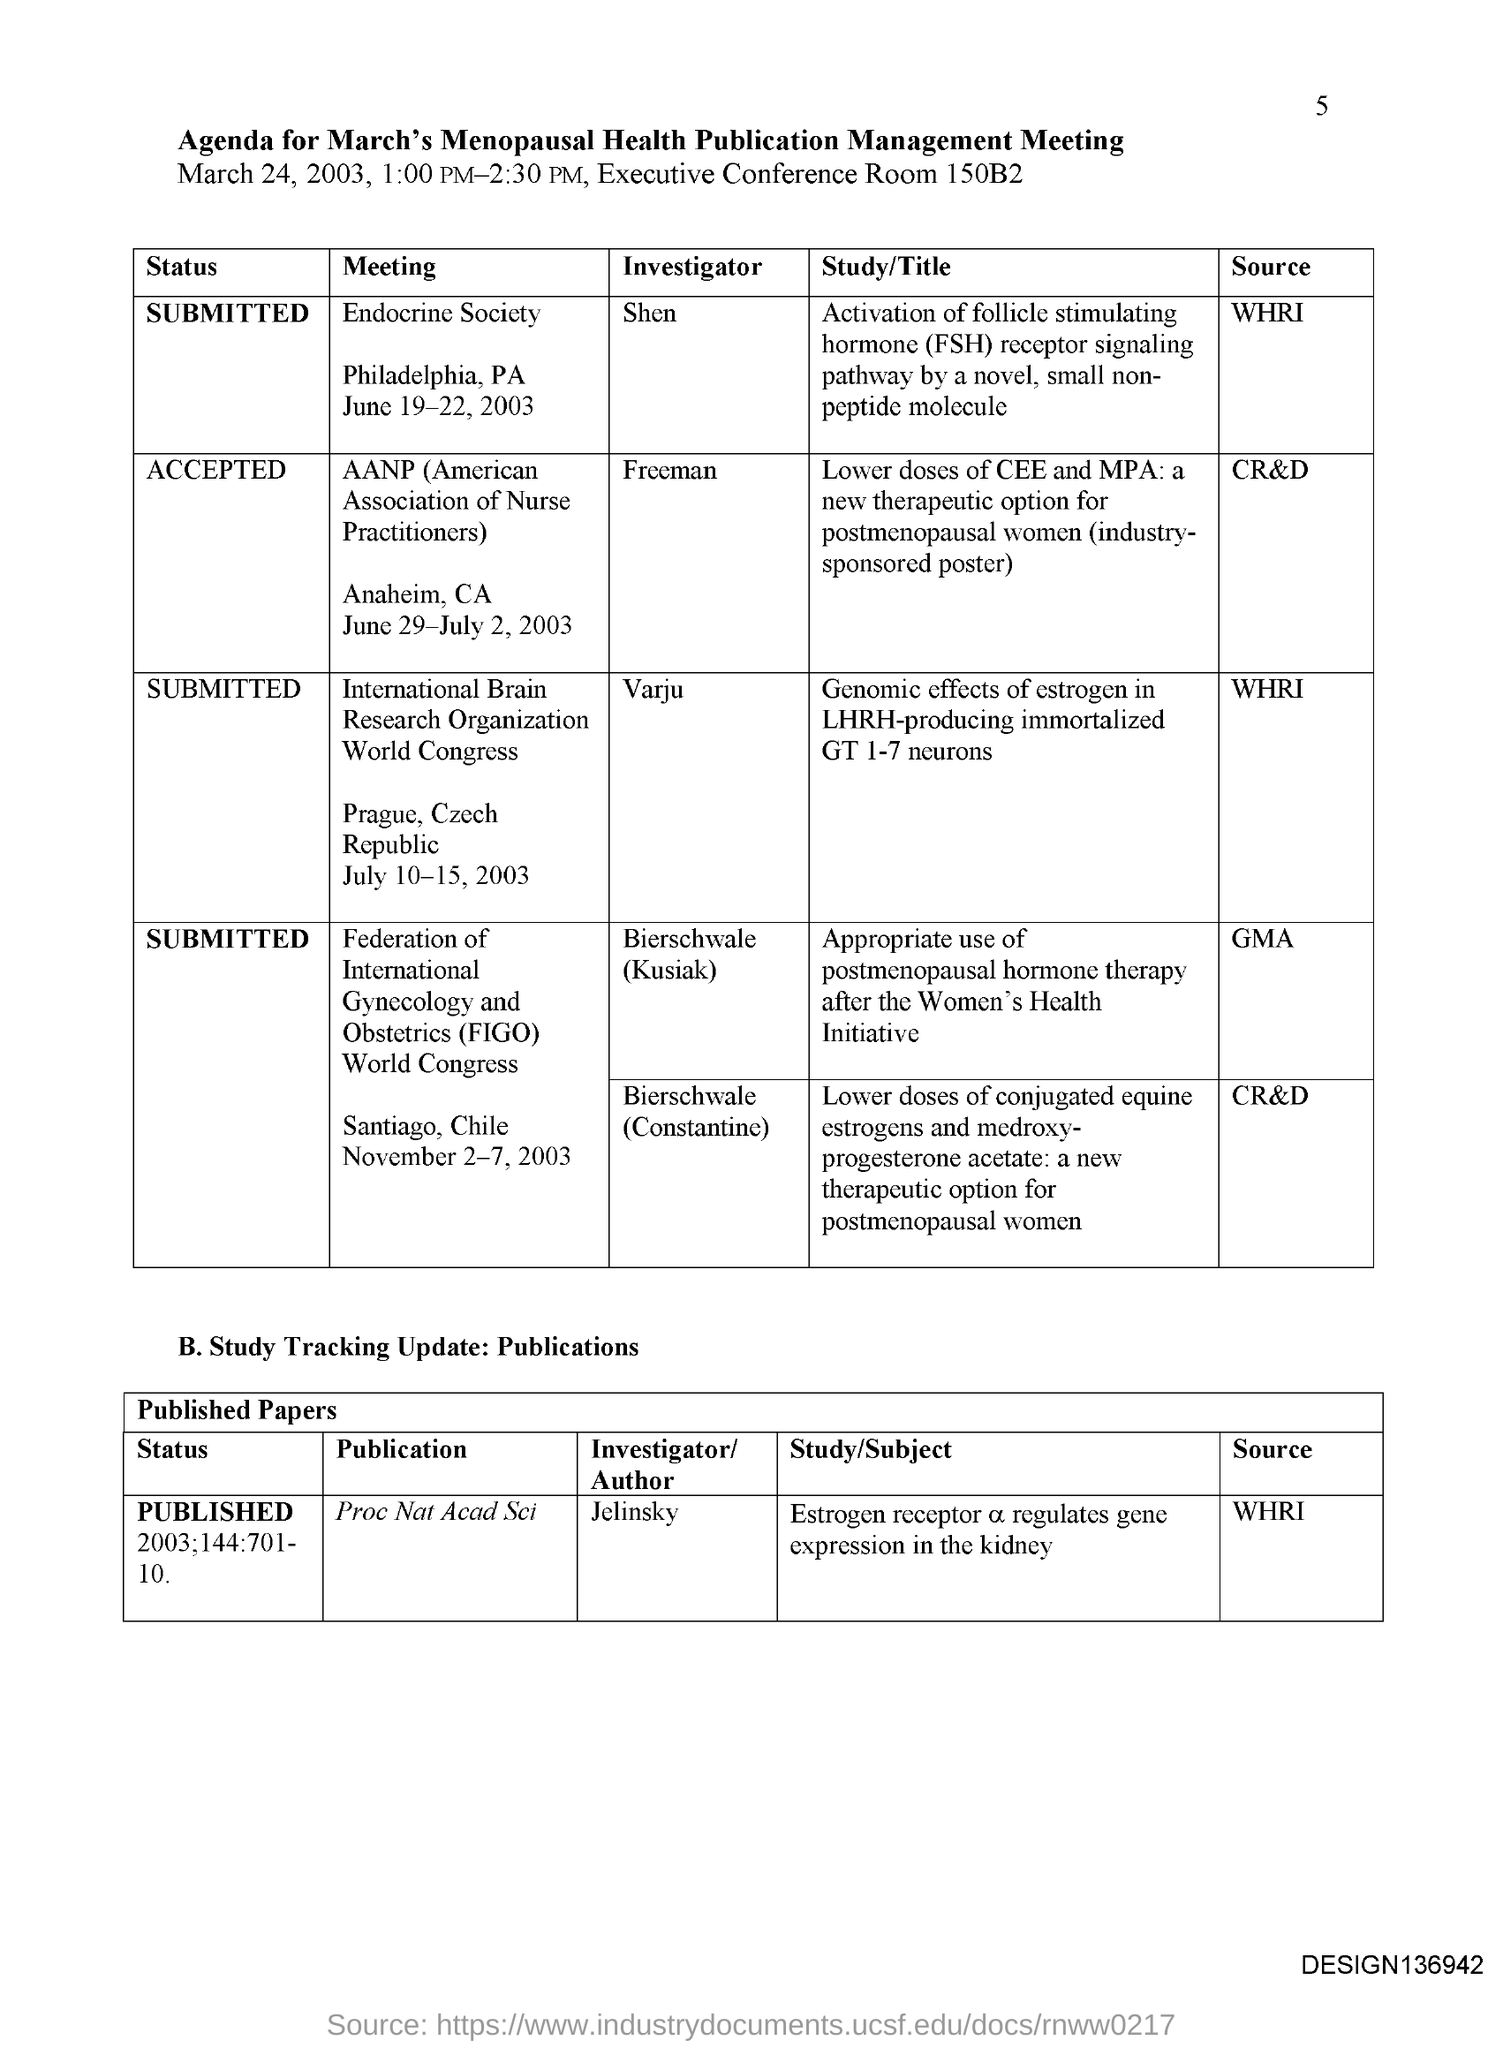Who is the Investigator for Endocrine Society meeting?
Your answer should be compact. Shen. Where is the Endocrine Society meeting held?
Your answer should be very brief. Philadelphia, PA. WheN is the Endocrine Society meeting held?
Keep it short and to the point. June 19-22, 2003. What is the Source for Endocrine Society meeting?
Provide a succinct answer. WHRI. Who is the Investigator for AANP meeting?
Give a very brief answer. Freeman. Where is the AANP meeting held at?
Ensure brevity in your answer.  Anaheim, CA. WheN is the AANP meeting held?
Give a very brief answer. June 29-July 2, 2003. Who is the Investigator for Publication "Proc Nat Acad Sci"?
Offer a very short reply. Jelinsky. What is the Source for Publication "Proc Nat Acad Sci"?
Keep it short and to the point. WHRI. 